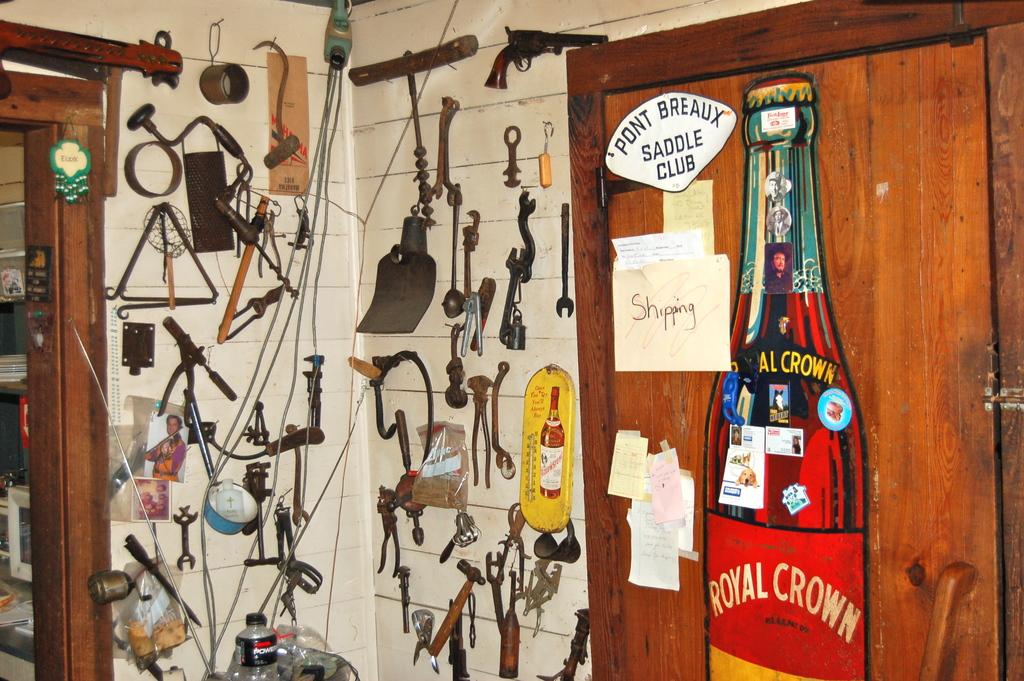What kind of soda is it?
Keep it short and to the point. Royal crown. 